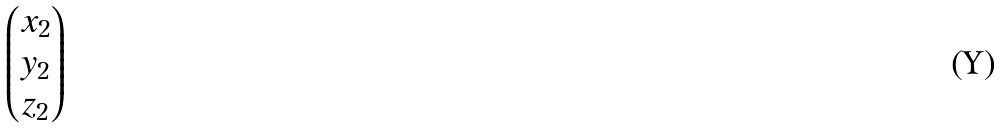Convert formula to latex. <formula><loc_0><loc_0><loc_500><loc_500>\begin{pmatrix} x _ { 2 } \\ y _ { 2 } \\ z _ { 2 } \end{pmatrix}</formula> 